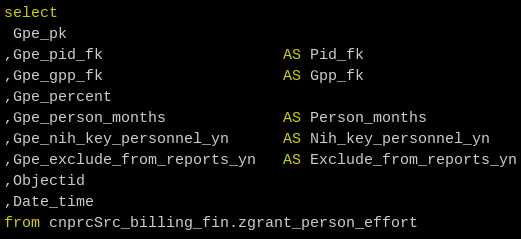Convert code to text. <code><loc_0><loc_0><loc_500><loc_500><_SQL_>select
 Gpe_pk
,Gpe_pid_fk                    AS Pid_fk
,Gpe_gpp_fk                    AS Gpp_fk
,Gpe_percent
,Gpe_person_months             AS Person_months
,Gpe_nih_key_personnel_yn      AS Nih_key_personnel_yn
,Gpe_exclude_from_reports_yn   AS Exclude_from_reports_yn
,Objectid
,Date_time
from cnprcSrc_billing_fin.zgrant_person_effort
</code> 